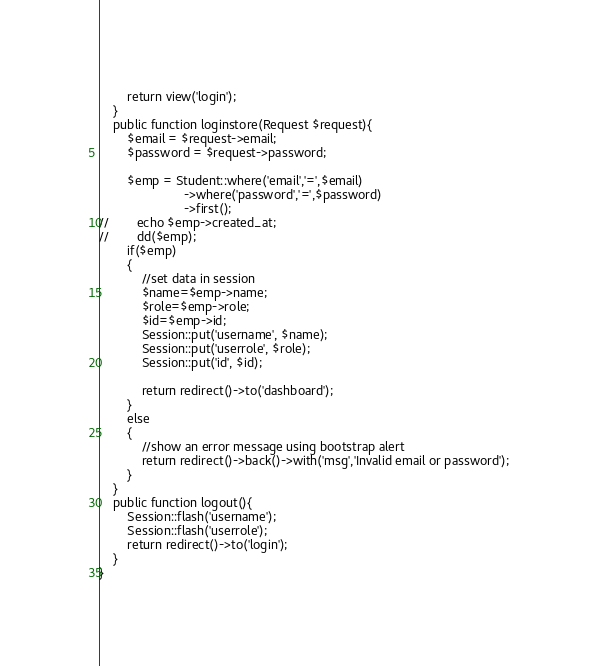<code> <loc_0><loc_0><loc_500><loc_500><_PHP_>        return view('login');
    }
    public function loginstore(Request $request){
        $email = $request->email;
        $password = $request->password;

        $emp = Student::where('email','=',$email)
                        ->where('password','=',$password)
                        ->first();
//        echo $emp->created_at;
//        dd($emp);
        if($emp)
        {
            //set data in session
            $name=$emp->name;
            $role=$emp->role;
            $id=$emp->id;
            Session::put('username', $name);
            Session::put('userrole', $role);
            Session::put('id', $id);

            return redirect()->to('dashboard');
        }
        else
        {
            //show an error message using bootstrap alert
            return redirect()->back()->with('msg','Invalid email or password');
        }
    }
    public function logout(){
        Session::flash('username');
        Session::flash('userrole');
        return redirect()->to('login');
    }
}
</code> 